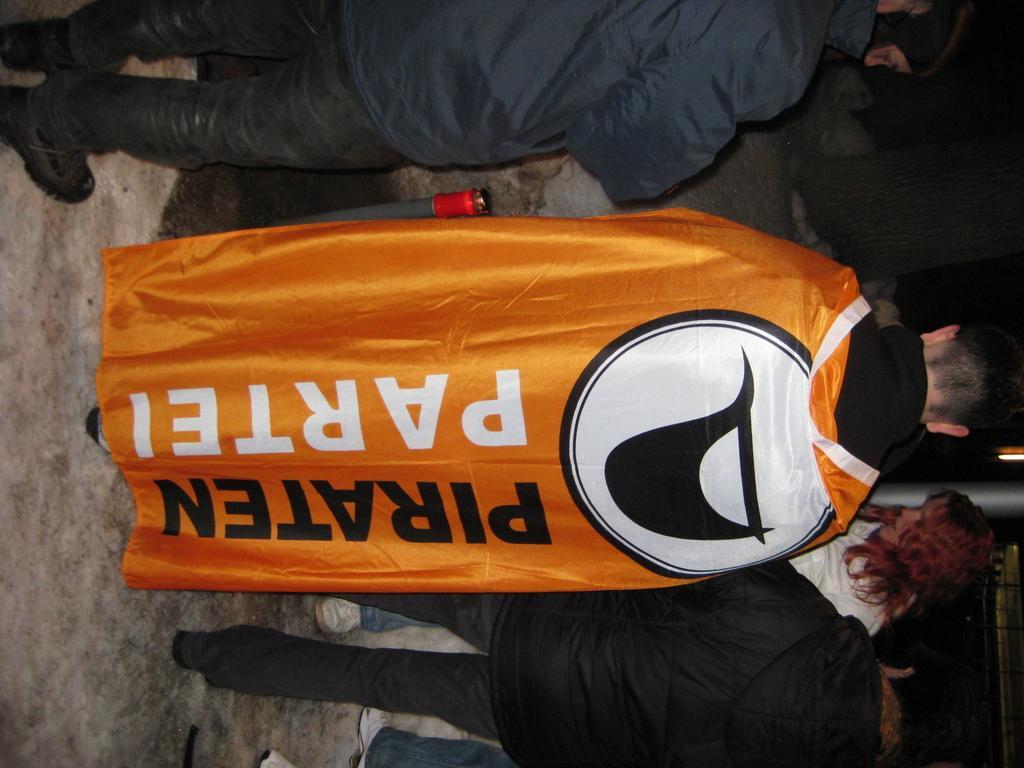Could you give a brief overview of what you see in this image? In this image I can see group of people standing. In front the person is wearing yellow and black color dress. In the background I can see the pole. 